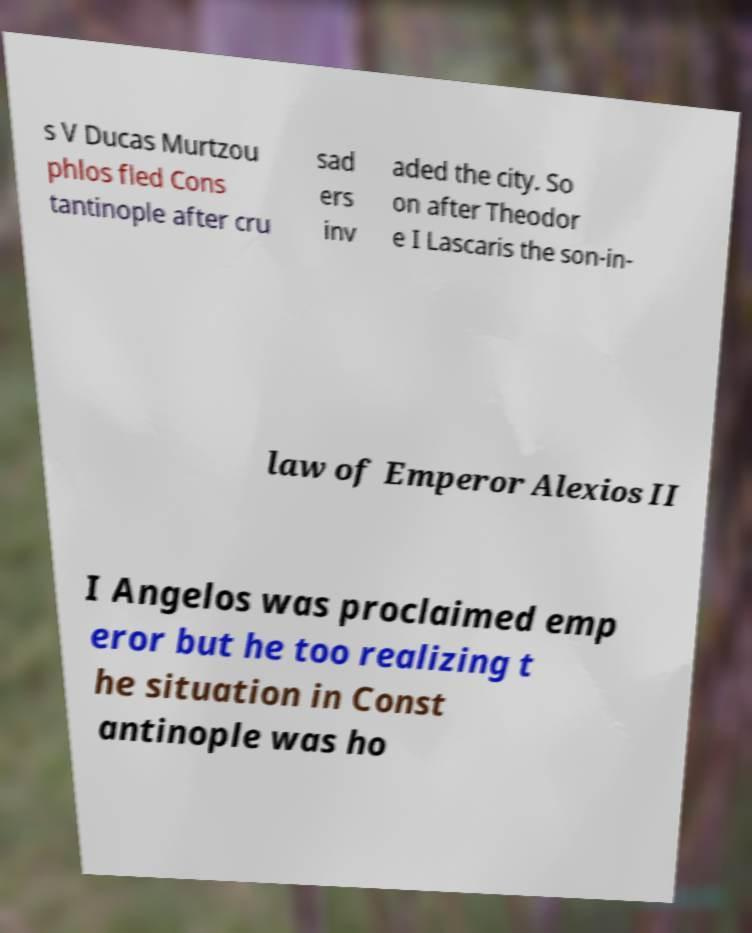Can you read and provide the text displayed in the image?This photo seems to have some interesting text. Can you extract and type it out for me? s V Ducas Murtzou phlos fled Cons tantinople after cru sad ers inv aded the city. So on after Theodor e I Lascaris the son-in- law of Emperor Alexios II I Angelos was proclaimed emp eror but he too realizing t he situation in Const antinople was ho 